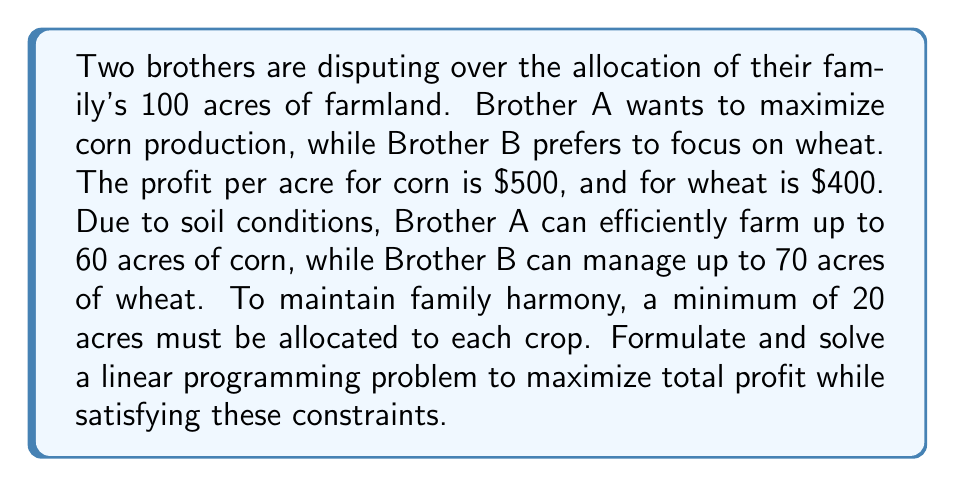Can you answer this question? Let's approach this step-by-step:

1) Define variables:
   Let $x$ be the number of acres allocated to corn
   Let $y$ be the number of acres allocated to wheat

2) Objective function:
   Maximize profit: $Z = 500x + 400y$

3) Constraints:
   Total land: $x + y \leq 100$
   Corn limit: $x \leq 60$
   Wheat limit: $y \leq 70$
   Minimum corn: $x \geq 20$
   Minimum wheat: $y \geq 20$
   Non-negativity: $x, y \geq 0$

4) Set up the linear programming problem:
   Maximize $Z = 500x + 400y$
   Subject to:
   $x + y \leq 100$
   $x \leq 60$
   $y \leq 70$
   $x \geq 20$
   $y \geq 20$
   $x, y \geq 0$

5) Solve using the graphical method:
   Plot the constraints on a coordinate system.
   The feasible region is the area that satisfies all constraints.

6) Find the corners of the feasible region:
   (20, 20), (20, 70), (60, 40), (60, 20)

7) Evaluate the objective function at each corner:
   (20, 20): $Z = 500(20) + 400(20) = 18,000$
   (20, 70): $Z = 500(20) + 400(70) = 38,000$
   (60, 40): $Z = 500(60) + 400(40) = 46,000$
   (60, 20): $Z = 500(60) + 400(20) = 38,000$

8) The maximum value occurs at (60, 40), which represents 60 acres of corn and 40 acres of wheat.
Answer: 60 acres corn, 40 acres wheat; $46,000 total profit 